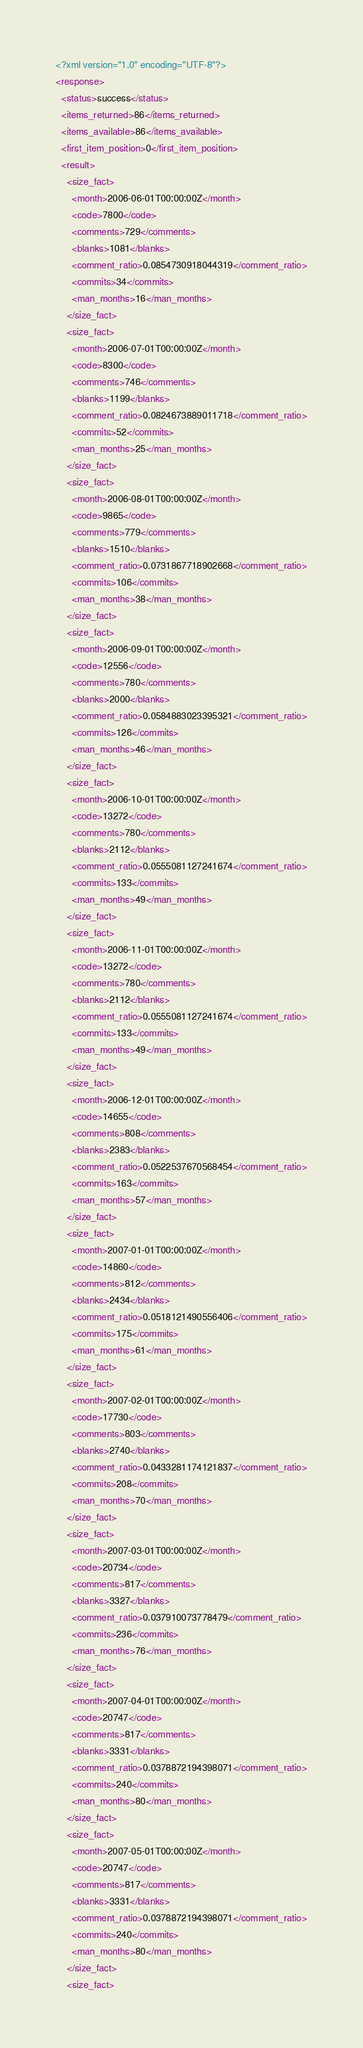Convert code to text. <code><loc_0><loc_0><loc_500><loc_500><_XML_><?xml version="1.0" encoding="UTF-8"?>
<response>
  <status>success</status>
  <items_returned>86</items_returned>
  <items_available>86</items_available>
  <first_item_position>0</first_item_position>
  <result>
    <size_fact>
      <month>2006-06-01T00:00:00Z</month>
      <code>7800</code>
      <comments>729</comments>
      <blanks>1081</blanks>
      <comment_ratio>0.0854730918044319</comment_ratio>
      <commits>34</commits>
      <man_months>16</man_months>
    </size_fact>
    <size_fact>
      <month>2006-07-01T00:00:00Z</month>
      <code>8300</code>
      <comments>746</comments>
      <blanks>1199</blanks>
      <comment_ratio>0.0824673889011718</comment_ratio>
      <commits>52</commits>
      <man_months>25</man_months>
    </size_fact>
    <size_fact>
      <month>2006-08-01T00:00:00Z</month>
      <code>9865</code>
      <comments>779</comments>
      <blanks>1510</blanks>
      <comment_ratio>0.0731867718902668</comment_ratio>
      <commits>106</commits>
      <man_months>38</man_months>
    </size_fact>
    <size_fact>
      <month>2006-09-01T00:00:00Z</month>
      <code>12556</code>
      <comments>780</comments>
      <blanks>2000</blanks>
      <comment_ratio>0.0584883023395321</comment_ratio>
      <commits>126</commits>
      <man_months>46</man_months>
    </size_fact>
    <size_fact>
      <month>2006-10-01T00:00:00Z</month>
      <code>13272</code>
      <comments>780</comments>
      <blanks>2112</blanks>
      <comment_ratio>0.0555081127241674</comment_ratio>
      <commits>133</commits>
      <man_months>49</man_months>
    </size_fact>
    <size_fact>
      <month>2006-11-01T00:00:00Z</month>
      <code>13272</code>
      <comments>780</comments>
      <blanks>2112</blanks>
      <comment_ratio>0.0555081127241674</comment_ratio>
      <commits>133</commits>
      <man_months>49</man_months>
    </size_fact>
    <size_fact>
      <month>2006-12-01T00:00:00Z</month>
      <code>14655</code>
      <comments>808</comments>
      <blanks>2383</blanks>
      <comment_ratio>0.0522537670568454</comment_ratio>
      <commits>163</commits>
      <man_months>57</man_months>
    </size_fact>
    <size_fact>
      <month>2007-01-01T00:00:00Z</month>
      <code>14860</code>
      <comments>812</comments>
      <blanks>2434</blanks>
      <comment_ratio>0.0518121490556406</comment_ratio>
      <commits>175</commits>
      <man_months>61</man_months>
    </size_fact>
    <size_fact>
      <month>2007-02-01T00:00:00Z</month>
      <code>17730</code>
      <comments>803</comments>
      <blanks>2740</blanks>
      <comment_ratio>0.0433281174121837</comment_ratio>
      <commits>208</commits>
      <man_months>70</man_months>
    </size_fact>
    <size_fact>
      <month>2007-03-01T00:00:00Z</month>
      <code>20734</code>
      <comments>817</comments>
      <blanks>3327</blanks>
      <comment_ratio>0.037910073778479</comment_ratio>
      <commits>236</commits>
      <man_months>76</man_months>
    </size_fact>
    <size_fact>
      <month>2007-04-01T00:00:00Z</month>
      <code>20747</code>
      <comments>817</comments>
      <blanks>3331</blanks>
      <comment_ratio>0.0378872194398071</comment_ratio>
      <commits>240</commits>
      <man_months>80</man_months>
    </size_fact>
    <size_fact>
      <month>2007-05-01T00:00:00Z</month>
      <code>20747</code>
      <comments>817</comments>
      <blanks>3331</blanks>
      <comment_ratio>0.0378872194398071</comment_ratio>
      <commits>240</commits>
      <man_months>80</man_months>
    </size_fact>
    <size_fact></code> 